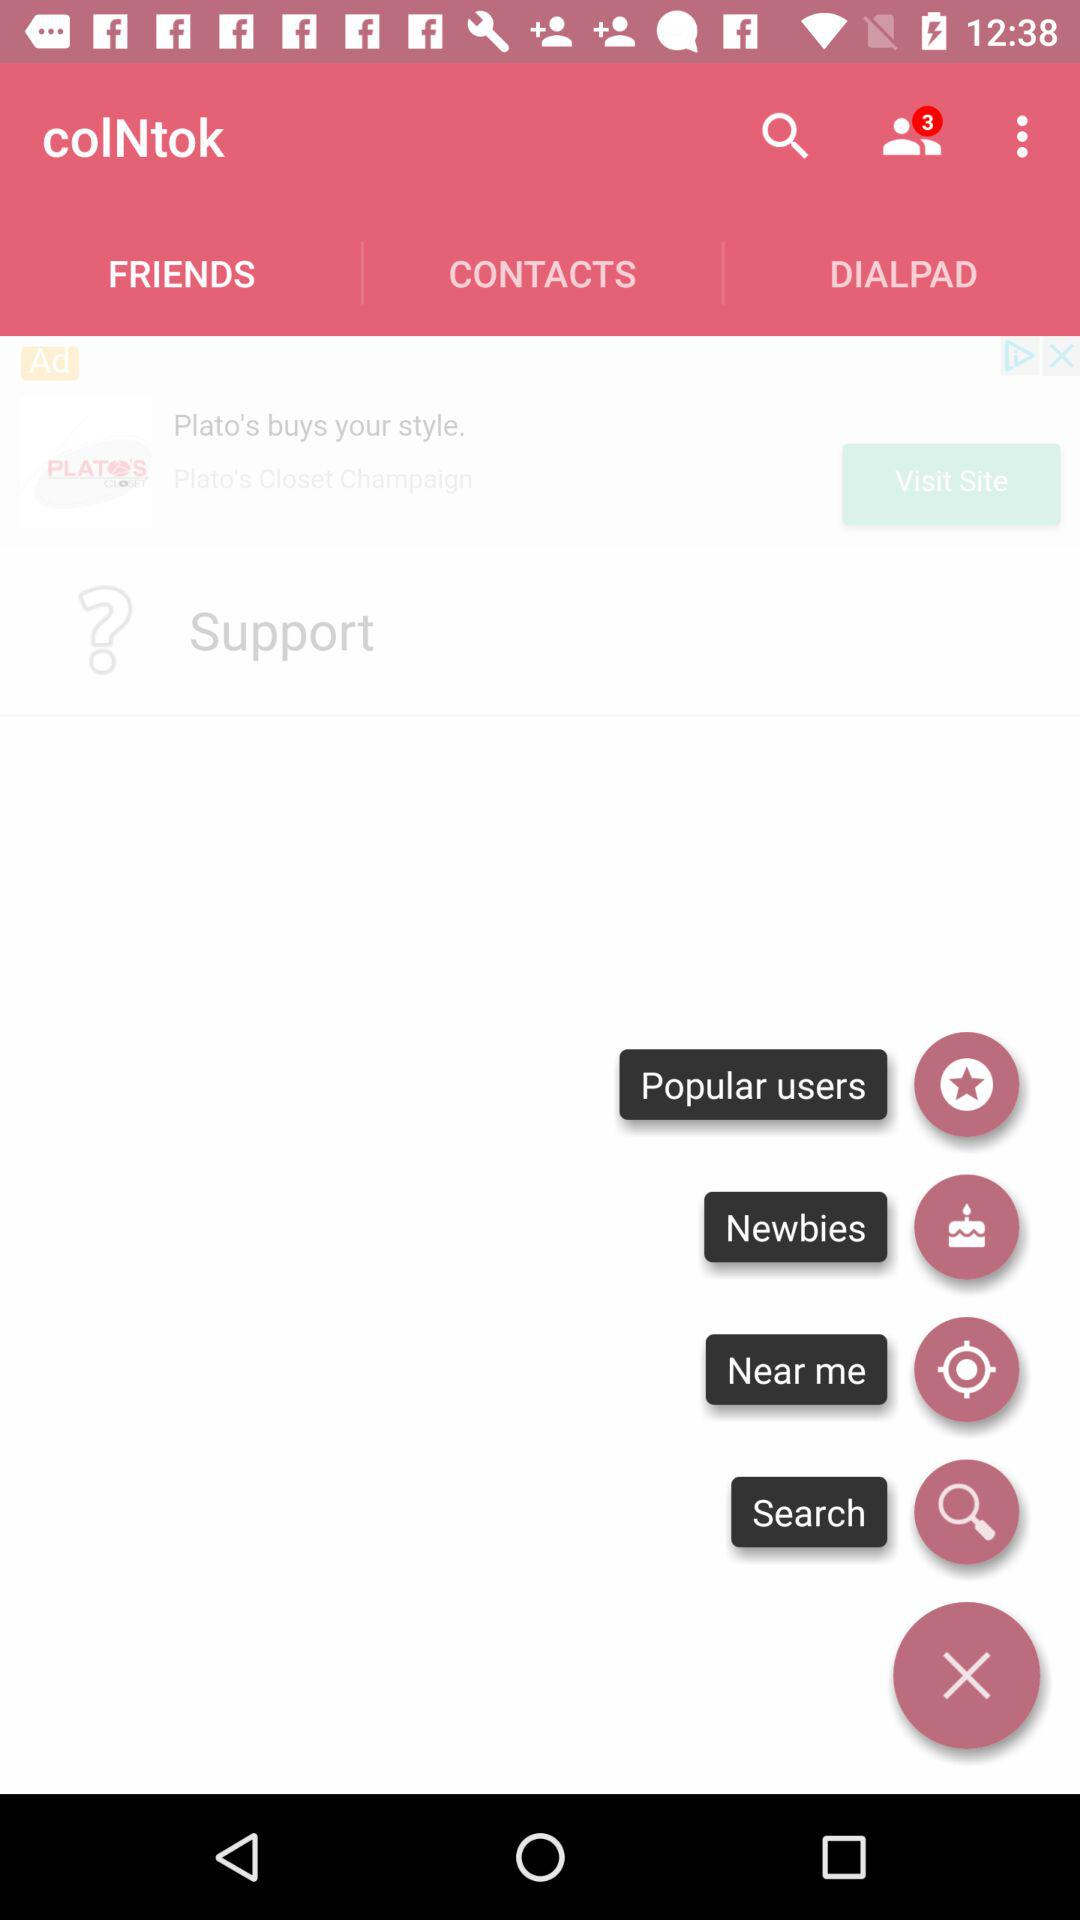Which tab is selected? The selected tab is "FRIENDS". 